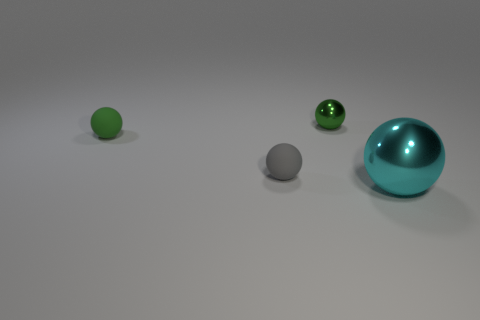There is a metallic sphere that is behind the tiny sphere in front of the rubber sphere on the left side of the small gray matte object; what color is it?
Offer a terse response. Green. How many gray things are cylinders or matte spheres?
Make the answer very short. 1. How many other things are the same size as the cyan shiny object?
Your answer should be compact. 0. What number of small green metal spheres are there?
Provide a succinct answer. 1. Is there anything else that has the same shape as the large object?
Ensure brevity in your answer.  Yes. Is the material of the green sphere in front of the green metal ball the same as the large cyan sphere right of the small shiny ball?
Keep it short and to the point. No. What is the large cyan thing made of?
Provide a short and direct response. Metal. What number of gray balls have the same material as the big thing?
Provide a succinct answer. 0. What number of metallic objects are either purple balls or gray things?
Offer a very short reply. 0. Do the metallic object that is behind the gray sphere and the cyan object that is to the right of the small green rubber sphere have the same shape?
Give a very brief answer. Yes. 